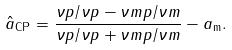<formula> <loc_0><loc_0><loc_500><loc_500>\hat { a } _ { \text {CP} } = \frac { \nu p / \nu p - \nu m p / \nu m } { \nu p / \nu p + \nu m p / \nu m } - a _ { \text {m} } .</formula> 